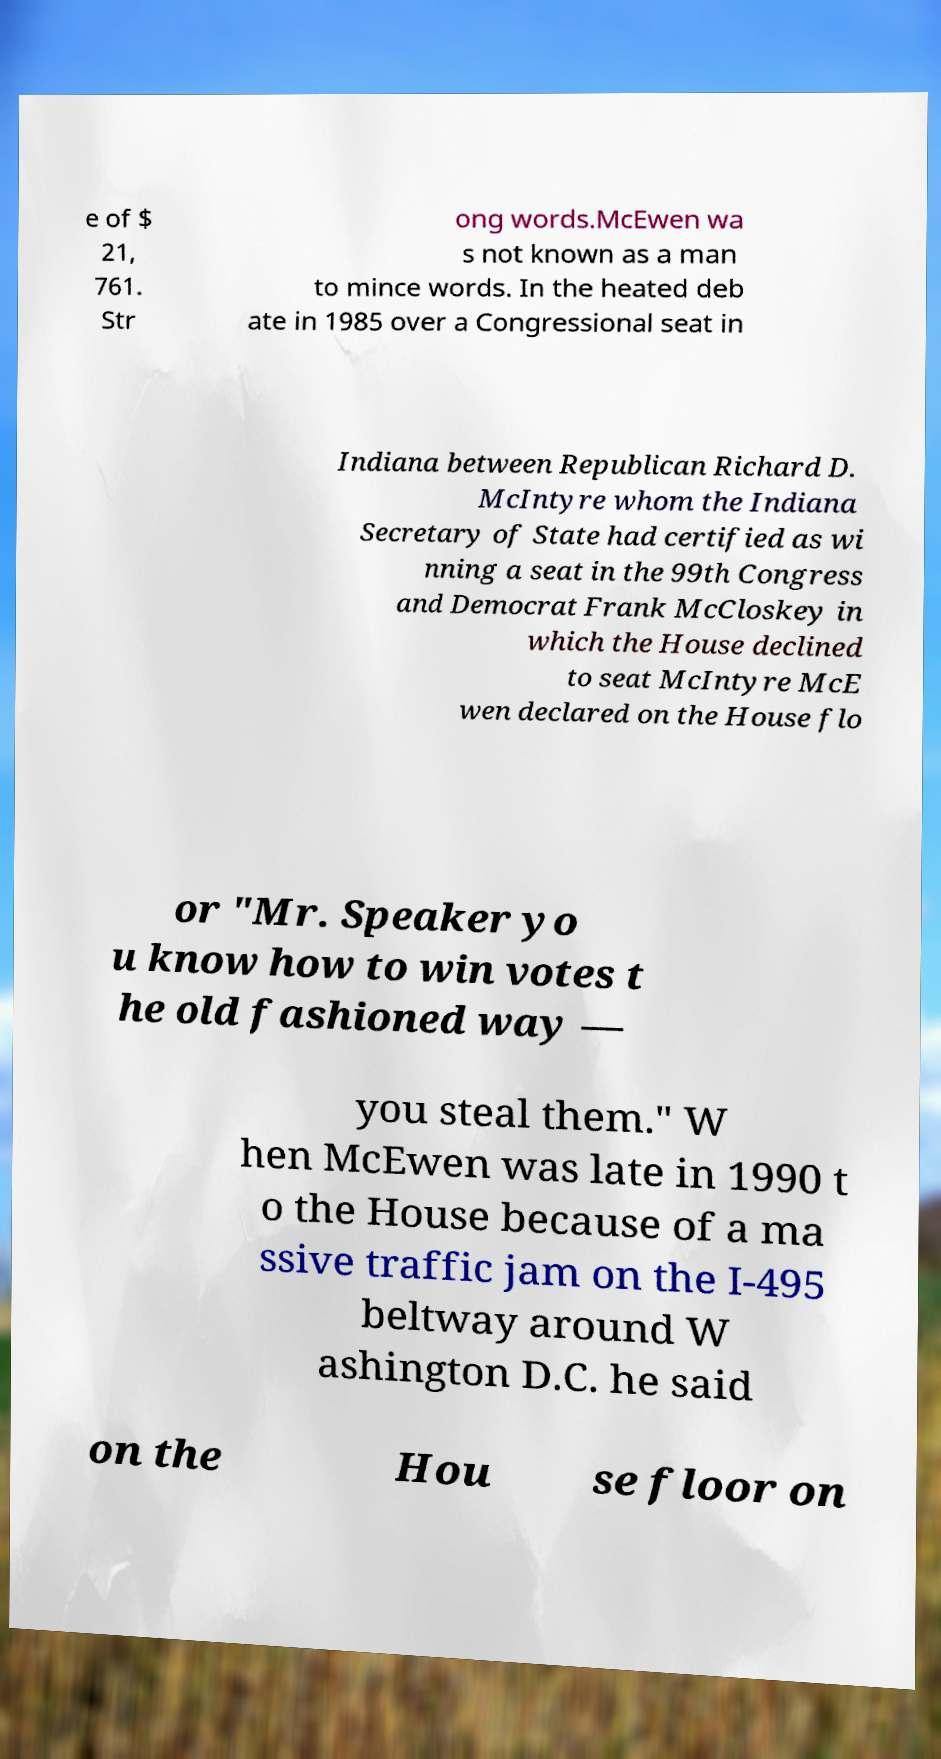Could you extract and type out the text from this image? e of $ 21, 761. Str ong words.McEwen wa s not known as a man to mince words. In the heated deb ate in 1985 over a Congressional seat in Indiana between Republican Richard D. McIntyre whom the Indiana Secretary of State had certified as wi nning a seat in the 99th Congress and Democrat Frank McCloskey in which the House declined to seat McIntyre McE wen declared on the House flo or "Mr. Speaker yo u know how to win votes t he old fashioned way — you steal them." W hen McEwen was late in 1990 t o the House because of a ma ssive traffic jam on the I-495 beltway around W ashington D.C. he said on the Hou se floor on 